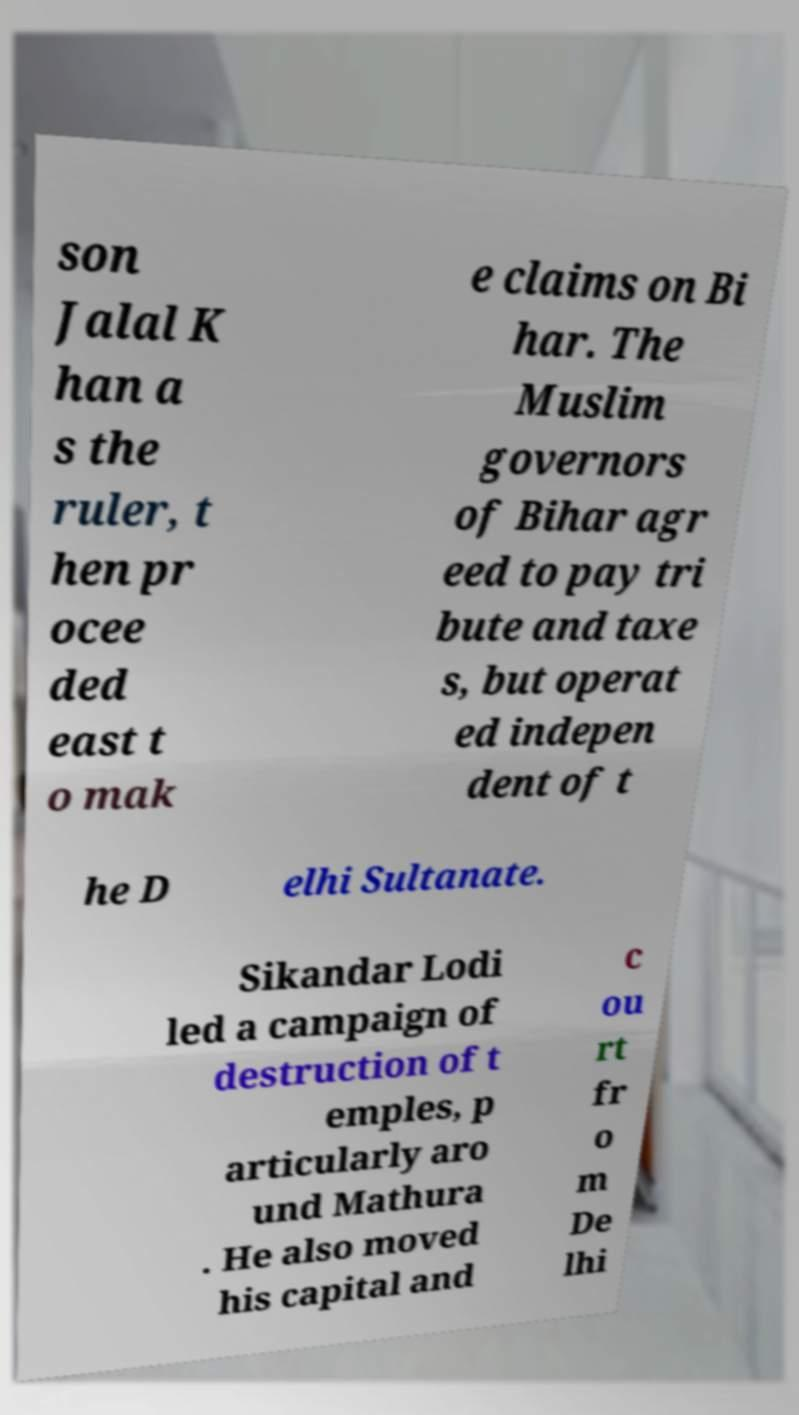What messages or text are displayed in this image? I need them in a readable, typed format. son Jalal K han a s the ruler, t hen pr ocee ded east t o mak e claims on Bi har. The Muslim governors of Bihar agr eed to pay tri bute and taxe s, but operat ed indepen dent of t he D elhi Sultanate. Sikandar Lodi led a campaign of destruction of t emples, p articularly aro und Mathura . He also moved his capital and c ou rt fr o m De lhi 